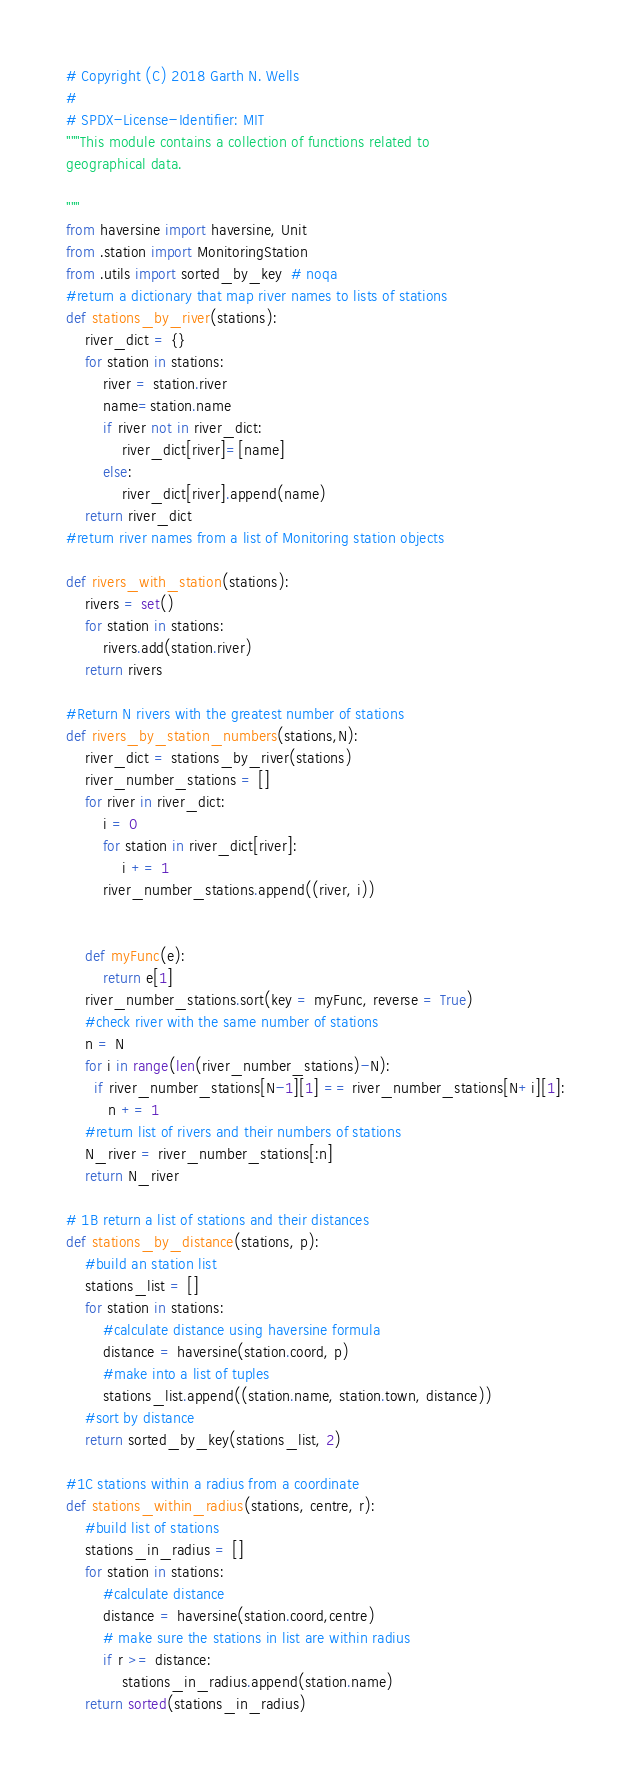Convert code to text. <code><loc_0><loc_0><loc_500><loc_500><_Python_># Copyright (C) 2018 Garth N. Wells
#
# SPDX-License-Identifier: MIT
"""This module contains a collection of functions related to
geographical data.

"""
from haversine import haversine, Unit
from .station import MonitoringStation
from .utils import sorted_by_key  # noqa
#return a dictionary that map river names to lists of stations 
def stations_by_river(stations):
    river_dict = {}
    for station in stations:
        river = station.river
        name=station.name
        if river not in river_dict:
            river_dict[river]=[name]
        else:
            river_dict[river].append(name)
    return river_dict
#return river names from a list of Monitoring station objects

def rivers_with_station(stations):
    rivers = set()
    for station in stations:
        rivers.add(station.river)
    return rivers

#Return N rivers with the greatest number of stations
def rivers_by_station_numbers(stations,N):
    river_dict = stations_by_river(stations)
    river_number_stations = []
    for river in river_dict:
        i = 0
        for station in river_dict[river]:
            i += 1
        river_number_stations.append((river, i))
    
    
    def myFunc(e):
        return e[1]
    river_number_stations.sort(key = myFunc, reverse = True)
    #check river with the same number of stations
    n = N
    for i in range(len(river_number_stations)-N):
      if river_number_stations[N-1][1] == river_number_stations[N+i][1]:
         n += 1
    #return list of rivers and their numbers of stations  
    N_river = river_number_stations[:n]
    return N_river
    
# 1B return a list of stations and their distances
def stations_by_distance(stations, p):
    #build an station list
    stations_list = []
    for station in stations:
        #calculate distance using haversine formula
        distance = haversine(station.coord, p)
        #make into a list of tuples
        stations_list.append((station.name, station.town, distance))
    #sort by distance
    return sorted_by_key(stations_list, 2)

#1C stations within a radius from a coordinate
def stations_within_radius(stations, centre, r):
    #build list of stations
    stations_in_radius = []
    for station in stations:
        #calculate distance
        distance = haversine(station.coord,centre)
        # make sure the stations in list are within radius
        if r >= distance:
            stations_in_radius.append(station.name)
    return sorted(stations_in_radius)
</code> 